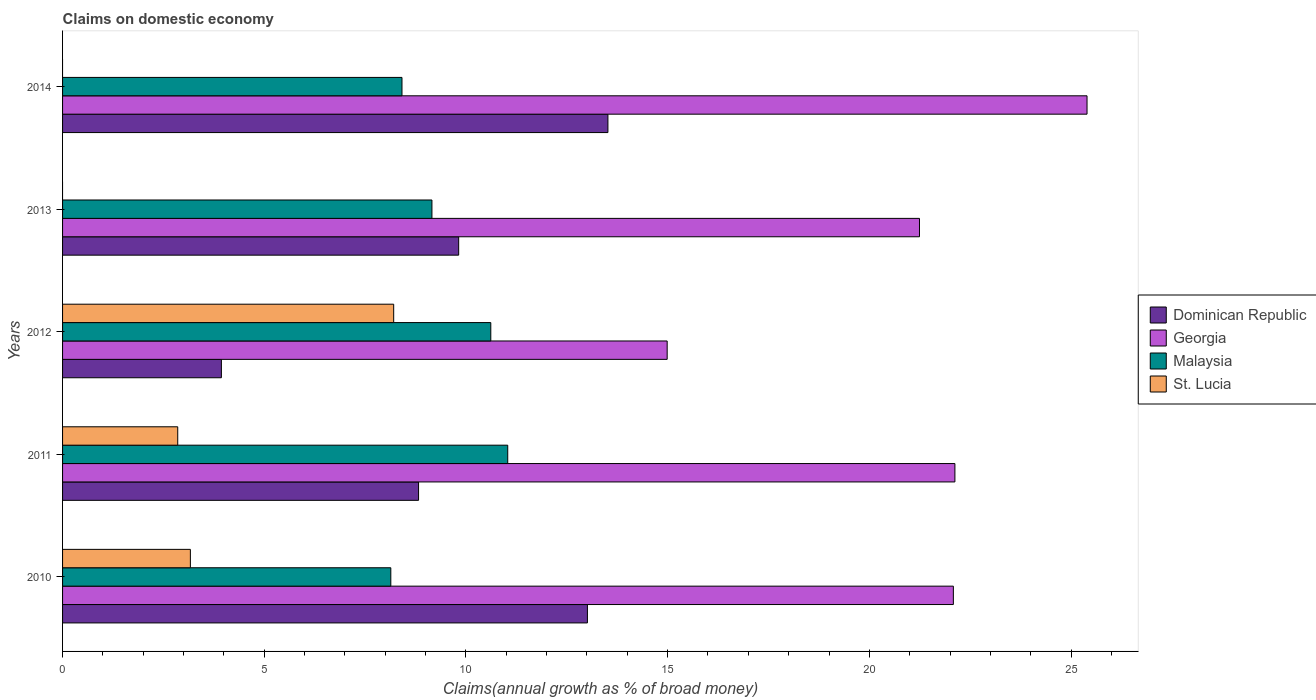How many groups of bars are there?
Your answer should be compact. 5. Are the number of bars per tick equal to the number of legend labels?
Give a very brief answer. No. What is the label of the 4th group of bars from the top?
Your response must be concise. 2011. What is the percentage of broad money claimed on domestic economy in Georgia in 2012?
Provide a short and direct response. 14.99. Across all years, what is the maximum percentage of broad money claimed on domestic economy in St. Lucia?
Provide a succinct answer. 8.21. Across all years, what is the minimum percentage of broad money claimed on domestic economy in Dominican Republic?
Ensure brevity in your answer.  3.94. In which year was the percentage of broad money claimed on domestic economy in Malaysia maximum?
Provide a succinct answer. 2011. What is the total percentage of broad money claimed on domestic economy in St. Lucia in the graph?
Provide a short and direct response. 14.23. What is the difference between the percentage of broad money claimed on domestic economy in Dominican Republic in 2011 and that in 2013?
Your response must be concise. -0.99. What is the difference between the percentage of broad money claimed on domestic economy in Malaysia in 2010 and the percentage of broad money claimed on domestic economy in St. Lucia in 2014?
Offer a very short reply. 8.14. What is the average percentage of broad money claimed on domestic economy in Dominican Republic per year?
Ensure brevity in your answer.  9.82. In the year 2010, what is the difference between the percentage of broad money claimed on domestic economy in Dominican Republic and percentage of broad money claimed on domestic economy in St. Lucia?
Your response must be concise. 9.84. In how many years, is the percentage of broad money claimed on domestic economy in Dominican Republic greater than 25 %?
Your response must be concise. 0. What is the ratio of the percentage of broad money claimed on domestic economy in Dominican Republic in 2011 to that in 2012?
Make the answer very short. 2.24. What is the difference between the highest and the second highest percentage of broad money claimed on domestic economy in Malaysia?
Keep it short and to the point. 0.42. What is the difference between the highest and the lowest percentage of broad money claimed on domestic economy in Georgia?
Your answer should be very brief. 10.41. In how many years, is the percentage of broad money claimed on domestic economy in Dominican Republic greater than the average percentage of broad money claimed on domestic economy in Dominican Republic taken over all years?
Keep it short and to the point. 2. Is the sum of the percentage of broad money claimed on domestic economy in Georgia in 2011 and 2013 greater than the maximum percentage of broad money claimed on domestic economy in St. Lucia across all years?
Your answer should be very brief. Yes. Is it the case that in every year, the sum of the percentage of broad money claimed on domestic economy in Georgia and percentage of broad money claimed on domestic economy in Malaysia is greater than the percentage of broad money claimed on domestic economy in St. Lucia?
Ensure brevity in your answer.  Yes. How many bars are there?
Your answer should be very brief. 18. What is the difference between two consecutive major ticks on the X-axis?
Make the answer very short. 5. Are the values on the major ticks of X-axis written in scientific E-notation?
Your answer should be compact. No. Does the graph contain any zero values?
Provide a short and direct response. Yes. Does the graph contain grids?
Ensure brevity in your answer.  No. How many legend labels are there?
Keep it short and to the point. 4. What is the title of the graph?
Keep it short and to the point. Claims on domestic economy. What is the label or title of the X-axis?
Your response must be concise. Claims(annual growth as % of broad money). What is the label or title of the Y-axis?
Your answer should be very brief. Years. What is the Claims(annual growth as % of broad money) of Dominican Republic in 2010?
Your answer should be compact. 13.01. What is the Claims(annual growth as % of broad money) of Georgia in 2010?
Offer a very short reply. 22.08. What is the Claims(annual growth as % of broad money) of Malaysia in 2010?
Keep it short and to the point. 8.14. What is the Claims(annual growth as % of broad money) of St. Lucia in 2010?
Your response must be concise. 3.17. What is the Claims(annual growth as % of broad money) of Dominican Republic in 2011?
Provide a succinct answer. 8.83. What is the Claims(annual growth as % of broad money) of Georgia in 2011?
Offer a terse response. 22.12. What is the Claims(annual growth as % of broad money) in Malaysia in 2011?
Your response must be concise. 11.04. What is the Claims(annual growth as % of broad money) of St. Lucia in 2011?
Your answer should be compact. 2.86. What is the Claims(annual growth as % of broad money) of Dominican Republic in 2012?
Make the answer very short. 3.94. What is the Claims(annual growth as % of broad money) in Georgia in 2012?
Give a very brief answer. 14.99. What is the Claims(annual growth as % of broad money) in Malaysia in 2012?
Keep it short and to the point. 10.62. What is the Claims(annual growth as % of broad money) of St. Lucia in 2012?
Give a very brief answer. 8.21. What is the Claims(annual growth as % of broad money) in Dominican Republic in 2013?
Your answer should be very brief. 9.82. What is the Claims(annual growth as % of broad money) of Georgia in 2013?
Offer a very short reply. 21.24. What is the Claims(annual growth as % of broad money) of Malaysia in 2013?
Provide a succinct answer. 9.16. What is the Claims(annual growth as % of broad money) of Dominican Republic in 2014?
Ensure brevity in your answer.  13.52. What is the Claims(annual growth as % of broad money) in Georgia in 2014?
Your response must be concise. 25.4. What is the Claims(annual growth as % of broad money) of Malaysia in 2014?
Provide a short and direct response. 8.41. Across all years, what is the maximum Claims(annual growth as % of broad money) in Dominican Republic?
Your answer should be very brief. 13.52. Across all years, what is the maximum Claims(annual growth as % of broad money) in Georgia?
Provide a short and direct response. 25.4. Across all years, what is the maximum Claims(annual growth as % of broad money) in Malaysia?
Offer a terse response. 11.04. Across all years, what is the maximum Claims(annual growth as % of broad money) in St. Lucia?
Your answer should be very brief. 8.21. Across all years, what is the minimum Claims(annual growth as % of broad money) in Dominican Republic?
Provide a short and direct response. 3.94. Across all years, what is the minimum Claims(annual growth as % of broad money) in Georgia?
Give a very brief answer. 14.99. Across all years, what is the minimum Claims(annual growth as % of broad money) in Malaysia?
Ensure brevity in your answer.  8.14. Across all years, what is the minimum Claims(annual growth as % of broad money) in St. Lucia?
Your answer should be compact. 0. What is the total Claims(annual growth as % of broad money) of Dominican Republic in the graph?
Your answer should be very brief. 49.11. What is the total Claims(annual growth as % of broad money) in Georgia in the graph?
Your answer should be compact. 105.83. What is the total Claims(annual growth as % of broad money) in Malaysia in the graph?
Give a very brief answer. 47.36. What is the total Claims(annual growth as % of broad money) of St. Lucia in the graph?
Ensure brevity in your answer.  14.23. What is the difference between the Claims(annual growth as % of broad money) of Dominican Republic in 2010 and that in 2011?
Ensure brevity in your answer.  4.19. What is the difference between the Claims(annual growth as % of broad money) in Georgia in 2010 and that in 2011?
Provide a short and direct response. -0.04. What is the difference between the Claims(annual growth as % of broad money) of Malaysia in 2010 and that in 2011?
Offer a very short reply. -2.9. What is the difference between the Claims(annual growth as % of broad money) of St. Lucia in 2010 and that in 2011?
Keep it short and to the point. 0.31. What is the difference between the Claims(annual growth as % of broad money) in Dominican Republic in 2010 and that in 2012?
Offer a terse response. 9.07. What is the difference between the Claims(annual growth as % of broad money) of Georgia in 2010 and that in 2012?
Your response must be concise. 7.09. What is the difference between the Claims(annual growth as % of broad money) in Malaysia in 2010 and that in 2012?
Your answer should be very brief. -2.48. What is the difference between the Claims(annual growth as % of broad money) of St. Lucia in 2010 and that in 2012?
Your answer should be very brief. -5.04. What is the difference between the Claims(annual growth as % of broad money) in Dominican Republic in 2010 and that in 2013?
Ensure brevity in your answer.  3.19. What is the difference between the Claims(annual growth as % of broad money) of Georgia in 2010 and that in 2013?
Your response must be concise. 0.84. What is the difference between the Claims(annual growth as % of broad money) in Malaysia in 2010 and that in 2013?
Ensure brevity in your answer.  -1.02. What is the difference between the Claims(annual growth as % of broad money) in Dominican Republic in 2010 and that in 2014?
Make the answer very short. -0.51. What is the difference between the Claims(annual growth as % of broad money) in Georgia in 2010 and that in 2014?
Your answer should be very brief. -3.31. What is the difference between the Claims(annual growth as % of broad money) of Malaysia in 2010 and that in 2014?
Your answer should be very brief. -0.28. What is the difference between the Claims(annual growth as % of broad money) of Dominican Republic in 2011 and that in 2012?
Your answer should be very brief. 4.89. What is the difference between the Claims(annual growth as % of broad money) of Georgia in 2011 and that in 2012?
Offer a very short reply. 7.13. What is the difference between the Claims(annual growth as % of broad money) of Malaysia in 2011 and that in 2012?
Offer a very short reply. 0.42. What is the difference between the Claims(annual growth as % of broad money) in St. Lucia in 2011 and that in 2012?
Offer a terse response. -5.35. What is the difference between the Claims(annual growth as % of broad money) in Dominican Republic in 2011 and that in 2013?
Your response must be concise. -0.99. What is the difference between the Claims(annual growth as % of broad money) of Georgia in 2011 and that in 2013?
Give a very brief answer. 0.88. What is the difference between the Claims(annual growth as % of broad money) of Malaysia in 2011 and that in 2013?
Ensure brevity in your answer.  1.88. What is the difference between the Claims(annual growth as % of broad money) in Dominican Republic in 2011 and that in 2014?
Ensure brevity in your answer.  -4.69. What is the difference between the Claims(annual growth as % of broad money) of Georgia in 2011 and that in 2014?
Provide a short and direct response. -3.28. What is the difference between the Claims(annual growth as % of broad money) in Malaysia in 2011 and that in 2014?
Make the answer very short. 2.62. What is the difference between the Claims(annual growth as % of broad money) of Dominican Republic in 2012 and that in 2013?
Offer a very short reply. -5.88. What is the difference between the Claims(annual growth as % of broad money) of Georgia in 2012 and that in 2013?
Give a very brief answer. -6.25. What is the difference between the Claims(annual growth as % of broad money) in Malaysia in 2012 and that in 2013?
Provide a succinct answer. 1.46. What is the difference between the Claims(annual growth as % of broad money) in Dominican Republic in 2012 and that in 2014?
Provide a short and direct response. -9.58. What is the difference between the Claims(annual growth as % of broad money) of Georgia in 2012 and that in 2014?
Your answer should be very brief. -10.41. What is the difference between the Claims(annual growth as % of broad money) of Malaysia in 2012 and that in 2014?
Keep it short and to the point. 2.2. What is the difference between the Claims(annual growth as % of broad money) of Dominican Republic in 2013 and that in 2014?
Your answer should be compact. -3.7. What is the difference between the Claims(annual growth as % of broad money) in Georgia in 2013 and that in 2014?
Your answer should be very brief. -4.15. What is the difference between the Claims(annual growth as % of broad money) in Malaysia in 2013 and that in 2014?
Your answer should be compact. 0.74. What is the difference between the Claims(annual growth as % of broad money) in Dominican Republic in 2010 and the Claims(annual growth as % of broad money) in Georgia in 2011?
Give a very brief answer. -9.11. What is the difference between the Claims(annual growth as % of broad money) in Dominican Republic in 2010 and the Claims(annual growth as % of broad money) in Malaysia in 2011?
Your answer should be compact. 1.98. What is the difference between the Claims(annual growth as % of broad money) of Dominican Republic in 2010 and the Claims(annual growth as % of broad money) of St. Lucia in 2011?
Your answer should be compact. 10.16. What is the difference between the Claims(annual growth as % of broad money) in Georgia in 2010 and the Claims(annual growth as % of broad money) in Malaysia in 2011?
Offer a very short reply. 11.05. What is the difference between the Claims(annual growth as % of broad money) of Georgia in 2010 and the Claims(annual growth as % of broad money) of St. Lucia in 2011?
Offer a very short reply. 19.23. What is the difference between the Claims(annual growth as % of broad money) of Malaysia in 2010 and the Claims(annual growth as % of broad money) of St. Lucia in 2011?
Make the answer very short. 5.28. What is the difference between the Claims(annual growth as % of broad money) in Dominican Republic in 2010 and the Claims(annual growth as % of broad money) in Georgia in 2012?
Make the answer very short. -1.98. What is the difference between the Claims(annual growth as % of broad money) in Dominican Republic in 2010 and the Claims(annual growth as % of broad money) in Malaysia in 2012?
Ensure brevity in your answer.  2.4. What is the difference between the Claims(annual growth as % of broad money) in Dominican Republic in 2010 and the Claims(annual growth as % of broad money) in St. Lucia in 2012?
Make the answer very short. 4.8. What is the difference between the Claims(annual growth as % of broad money) of Georgia in 2010 and the Claims(annual growth as % of broad money) of Malaysia in 2012?
Your answer should be compact. 11.47. What is the difference between the Claims(annual growth as % of broad money) of Georgia in 2010 and the Claims(annual growth as % of broad money) of St. Lucia in 2012?
Your answer should be very brief. 13.87. What is the difference between the Claims(annual growth as % of broad money) of Malaysia in 2010 and the Claims(annual growth as % of broad money) of St. Lucia in 2012?
Give a very brief answer. -0.07. What is the difference between the Claims(annual growth as % of broad money) in Dominican Republic in 2010 and the Claims(annual growth as % of broad money) in Georgia in 2013?
Keep it short and to the point. -8.23. What is the difference between the Claims(annual growth as % of broad money) of Dominican Republic in 2010 and the Claims(annual growth as % of broad money) of Malaysia in 2013?
Offer a terse response. 3.85. What is the difference between the Claims(annual growth as % of broad money) in Georgia in 2010 and the Claims(annual growth as % of broad money) in Malaysia in 2013?
Provide a short and direct response. 12.93. What is the difference between the Claims(annual growth as % of broad money) in Dominican Republic in 2010 and the Claims(annual growth as % of broad money) in Georgia in 2014?
Offer a very short reply. -12.39. What is the difference between the Claims(annual growth as % of broad money) in Dominican Republic in 2010 and the Claims(annual growth as % of broad money) in Malaysia in 2014?
Your answer should be compact. 4.6. What is the difference between the Claims(annual growth as % of broad money) of Georgia in 2010 and the Claims(annual growth as % of broad money) of Malaysia in 2014?
Make the answer very short. 13.67. What is the difference between the Claims(annual growth as % of broad money) of Dominican Republic in 2011 and the Claims(annual growth as % of broad money) of Georgia in 2012?
Provide a short and direct response. -6.16. What is the difference between the Claims(annual growth as % of broad money) of Dominican Republic in 2011 and the Claims(annual growth as % of broad money) of Malaysia in 2012?
Your response must be concise. -1.79. What is the difference between the Claims(annual growth as % of broad money) in Dominican Republic in 2011 and the Claims(annual growth as % of broad money) in St. Lucia in 2012?
Give a very brief answer. 0.62. What is the difference between the Claims(annual growth as % of broad money) in Georgia in 2011 and the Claims(annual growth as % of broad money) in Malaysia in 2012?
Ensure brevity in your answer.  11.51. What is the difference between the Claims(annual growth as % of broad money) of Georgia in 2011 and the Claims(annual growth as % of broad money) of St. Lucia in 2012?
Your response must be concise. 13.91. What is the difference between the Claims(annual growth as % of broad money) in Malaysia in 2011 and the Claims(annual growth as % of broad money) in St. Lucia in 2012?
Your response must be concise. 2.83. What is the difference between the Claims(annual growth as % of broad money) in Dominican Republic in 2011 and the Claims(annual growth as % of broad money) in Georgia in 2013?
Your response must be concise. -12.42. What is the difference between the Claims(annual growth as % of broad money) in Dominican Republic in 2011 and the Claims(annual growth as % of broad money) in Malaysia in 2013?
Keep it short and to the point. -0.33. What is the difference between the Claims(annual growth as % of broad money) of Georgia in 2011 and the Claims(annual growth as % of broad money) of Malaysia in 2013?
Offer a very short reply. 12.96. What is the difference between the Claims(annual growth as % of broad money) of Dominican Republic in 2011 and the Claims(annual growth as % of broad money) of Georgia in 2014?
Make the answer very short. -16.57. What is the difference between the Claims(annual growth as % of broad money) in Dominican Republic in 2011 and the Claims(annual growth as % of broad money) in Malaysia in 2014?
Provide a succinct answer. 0.41. What is the difference between the Claims(annual growth as % of broad money) in Georgia in 2011 and the Claims(annual growth as % of broad money) in Malaysia in 2014?
Your answer should be compact. 13.71. What is the difference between the Claims(annual growth as % of broad money) of Dominican Republic in 2012 and the Claims(annual growth as % of broad money) of Georgia in 2013?
Offer a very short reply. -17.31. What is the difference between the Claims(annual growth as % of broad money) of Dominican Republic in 2012 and the Claims(annual growth as % of broad money) of Malaysia in 2013?
Ensure brevity in your answer.  -5.22. What is the difference between the Claims(annual growth as % of broad money) in Georgia in 2012 and the Claims(annual growth as % of broad money) in Malaysia in 2013?
Offer a terse response. 5.83. What is the difference between the Claims(annual growth as % of broad money) in Dominican Republic in 2012 and the Claims(annual growth as % of broad money) in Georgia in 2014?
Your answer should be compact. -21.46. What is the difference between the Claims(annual growth as % of broad money) of Dominican Republic in 2012 and the Claims(annual growth as % of broad money) of Malaysia in 2014?
Your answer should be very brief. -4.48. What is the difference between the Claims(annual growth as % of broad money) of Georgia in 2012 and the Claims(annual growth as % of broad money) of Malaysia in 2014?
Your response must be concise. 6.57. What is the difference between the Claims(annual growth as % of broad money) in Dominican Republic in 2013 and the Claims(annual growth as % of broad money) in Georgia in 2014?
Your response must be concise. -15.58. What is the difference between the Claims(annual growth as % of broad money) in Dominican Republic in 2013 and the Claims(annual growth as % of broad money) in Malaysia in 2014?
Provide a succinct answer. 1.41. What is the difference between the Claims(annual growth as % of broad money) of Georgia in 2013 and the Claims(annual growth as % of broad money) of Malaysia in 2014?
Offer a very short reply. 12.83. What is the average Claims(annual growth as % of broad money) of Dominican Republic per year?
Provide a succinct answer. 9.82. What is the average Claims(annual growth as % of broad money) of Georgia per year?
Offer a very short reply. 21.17. What is the average Claims(annual growth as % of broad money) in Malaysia per year?
Give a very brief answer. 9.47. What is the average Claims(annual growth as % of broad money) in St. Lucia per year?
Keep it short and to the point. 2.85. In the year 2010, what is the difference between the Claims(annual growth as % of broad money) of Dominican Republic and Claims(annual growth as % of broad money) of Georgia?
Your response must be concise. -9.07. In the year 2010, what is the difference between the Claims(annual growth as % of broad money) in Dominican Republic and Claims(annual growth as % of broad money) in Malaysia?
Offer a terse response. 4.87. In the year 2010, what is the difference between the Claims(annual growth as % of broad money) of Dominican Republic and Claims(annual growth as % of broad money) of St. Lucia?
Your answer should be very brief. 9.84. In the year 2010, what is the difference between the Claims(annual growth as % of broad money) in Georgia and Claims(annual growth as % of broad money) in Malaysia?
Provide a short and direct response. 13.95. In the year 2010, what is the difference between the Claims(annual growth as % of broad money) in Georgia and Claims(annual growth as % of broad money) in St. Lucia?
Offer a very short reply. 18.91. In the year 2010, what is the difference between the Claims(annual growth as % of broad money) in Malaysia and Claims(annual growth as % of broad money) in St. Lucia?
Ensure brevity in your answer.  4.97. In the year 2011, what is the difference between the Claims(annual growth as % of broad money) in Dominican Republic and Claims(annual growth as % of broad money) in Georgia?
Your answer should be very brief. -13.3. In the year 2011, what is the difference between the Claims(annual growth as % of broad money) of Dominican Republic and Claims(annual growth as % of broad money) of Malaysia?
Provide a succinct answer. -2.21. In the year 2011, what is the difference between the Claims(annual growth as % of broad money) in Dominican Republic and Claims(annual growth as % of broad money) in St. Lucia?
Keep it short and to the point. 5.97. In the year 2011, what is the difference between the Claims(annual growth as % of broad money) in Georgia and Claims(annual growth as % of broad money) in Malaysia?
Offer a very short reply. 11.09. In the year 2011, what is the difference between the Claims(annual growth as % of broad money) of Georgia and Claims(annual growth as % of broad money) of St. Lucia?
Your answer should be very brief. 19.27. In the year 2011, what is the difference between the Claims(annual growth as % of broad money) in Malaysia and Claims(annual growth as % of broad money) in St. Lucia?
Your answer should be compact. 8.18. In the year 2012, what is the difference between the Claims(annual growth as % of broad money) of Dominican Republic and Claims(annual growth as % of broad money) of Georgia?
Provide a succinct answer. -11.05. In the year 2012, what is the difference between the Claims(annual growth as % of broad money) in Dominican Republic and Claims(annual growth as % of broad money) in Malaysia?
Provide a succinct answer. -6.68. In the year 2012, what is the difference between the Claims(annual growth as % of broad money) of Dominican Republic and Claims(annual growth as % of broad money) of St. Lucia?
Ensure brevity in your answer.  -4.27. In the year 2012, what is the difference between the Claims(annual growth as % of broad money) in Georgia and Claims(annual growth as % of broad money) in Malaysia?
Keep it short and to the point. 4.37. In the year 2012, what is the difference between the Claims(annual growth as % of broad money) in Georgia and Claims(annual growth as % of broad money) in St. Lucia?
Ensure brevity in your answer.  6.78. In the year 2012, what is the difference between the Claims(annual growth as % of broad money) of Malaysia and Claims(annual growth as % of broad money) of St. Lucia?
Your answer should be compact. 2.41. In the year 2013, what is the difference between the Claims(annual growth as % of broad money) of Dominican Republic and Claims(annual growth as % of broad money) of Georgia?
Provide a short and direct response. -11.42. In the year 2013, what is the difference between the Claims(annual growth as % of broad money) in Dominican Republic and Claims(annual growth as % of broad money) in Malaysia?
Ensure brevity in your answer.  0.66. In the year 2013, what is the difference between the Claims(annual growth as % of broad money) of Georgia and Claims(annual growth as % of broad money) of Malaysia?
Offer a terse response. 12.09. In the year 2014, what is the difference between the Claims(annual growth as % of broad money) of Dominican Republic and Claims(annual growth as % of broad money) of Georgia?
Your answer should be compact. -11.88. In the year 2014, what is the difference between the Claims(annual growth as % of broad money) in Dominican Republic and Claims(annual growth as % of broad money) in Malaysia?
Ensure brevity in your answer.  5.11. In the year 2014, what is the difference between the Claims(annual growth as % of broad money) of Georgia and Claims(annual growth as % of broad money) of Malaysia?
Give a very brief answer. 16.98. What is the ratio of the Claims(annual growth as % of broad money) in Dominican Republic in 2010 to that in 2011?
Give a very brief answer. 1.47. What is the ratio of the Claims(annual growth as % of broad money) in Malaysia in 2010 to that in 2011?
Keep it short and to the point. 0.74. What is the ratio of the Claims(annual growth as % of broad money) in St. Lucia in 2010 to that in 2011?
Ensure brevity in your answer.  1.11. What is the ratio of the Claims(annual growth as % of broad money) in Dominican Republic in 2010 to that in 2012?
Your answer should be compact. 3.3. What is the ratio of the Claims(annual growth as % of broad money) in Georgia in 2010 to that in 2012?
Make the answer very short. 1.47. What is the ratio of the Claims(annual growth as % of broad money) of Malaysia in 2010 to that in 2012?
Offer a very short reply. 0.77. What is the ratio of the Claims(annual growth as % of broad money) of St. Lucia in 2010 to that in 2012?
Your answer should be very brief. 0.39. What is the ratio of the Claims(annual growth as % of broad money) in Dominican Republic in 2010 to that in 2013?
Your response must be concise. 1.32. What is the ratio of the Claims(annual growth as % of broad money) of Georgia in 2010 to that in 2013?
Your response must be concise. 1.04. What is the ratio of the Claims(annual growth as % of broad money) in Malaysia in 2010 to that in 2013?
Offer a terse response. 0.89. What is the ratio of the Claims(annual growth as % of broad money) of Dominican Republic in 2010 to that in 2014?
Your answer should be compact. 0.96. What is the ratio of the Claims(annual growth as % of broad money) of Georgia in 2010 to that in 2014?
Your answer should be compact. 0.87. What is the ratio of the Claims(annual growth as % of broad money) of Malaysia in 2010 to that in 2014?
Your answer should be compact. 0.97. What is the ratio of the Claims(annual growth as % of broad money) in Dominican Republic in 2011 to that in 2012?
Keep it short and to the point. 2.24. What is the ratio of the Claims(annual growth as % of broad money) of Georgia in 2011 to that in 2012?
Ensure brevity in your answer.  1.48. What is the ratio of the Claims(annual growth as % of broad money) in Malaysia in 2011 to that in 2012?
Ensure brevity in your answer.  1.04. What is the ratio of the Claims(annual growth as % of broad money) of St. Lucia in 2011 to that in 2012?
Your answer should be very brief. 0.35. What is the ratio of the Claims(annual growth as % of broad money) of Dominican Republic in 2011 to that in 2013?
Offer a terse response. 0.9. What is the ratio of the Claims(annual growth as % of broad money) in Georgia in 2011 to that in 2013?
Ensure brevity in your answer.  1.04. What is the ratio of the Claims(annual growth as % of broad money) in Malaysia in 2011 to that in 2013?
Make the answer very short. 1.21. What is the ratio of the Claims(annual growth as % of broad money) in Dominican Republic in 2011 to that in 2014?
Your response must be concise. 0.65. What is the ratio of the Claims(annual growth as % of broad money) of Georgia in 2011 to that in 2014?
Provide a succinct answer. 0.87. What is the ratio of the Claims(annual growth as % of broad money) of Malaysia in 2011 to that in 2014?
Your answer should be very brief. 1.31. What is the ratio of the Claims(annual growth as % of broad money) in Dominican Republic in 2012 to that in 2013?
Make the answer very short. 0.4. What is the ratio of the Claims(annual growth as % of broad money) of Georgia in 2012 to that in 2013?
Give a very brief answer. 0.71. What is the ratio of the Claims(annual growth as % of broad money) of Malaysia in 2012 to that in 2013?
Give a very brief answer. 1.16. What is the ratio of the Claims(annual growth as % of broad money) in Dominican Republic in 2012 to that in 2014?
Provide a succinct answer. 0.29. What is the ratio of the Claims(annual growth as % of broad money) in Georgia in 2012 to that in 2014?
Offer a terse response. 0.59. What is the ratio of the Claims(annual growth as % of broad money) in Malaysia in 2012 to that in 2014?
Your answer should be very brief. 1.26. What is the ratio of the Claims(annual growth as % of broad money) in Dominican Republic in 2013 to that in 2014?
Your answer should be compact. 0.73. What is the ratio of the Claims(annual growth as % of broad money) in Georgia in 2013 to that in 2014?
Your answer should be very brief. 0.84. What is the ratio of the Claims(annual growth as % of broad money) of Malaysia in 2013 to that in 2014?
Offer a terse response. 1.09. What is the difference between the highest and the second highest Claims(annual growth as % of broad money) in Dominican Republic?
Give a very brief answer. 0.51. What is the difference between the highest and the second highest Claims(annual growth as % of broad money) of Georgia?
Provide a succinct answer. 3.28. What is the difference between the highest and the second highest Claims(annual growth as % of broad money) in Malaysia?
Keep it short and to the point. 0.42. What is the difference between the highest and the second highest Claims(annual growth as % of broad money) in St. Lucia?
Ensure brevity in your answer.  5.04. What is the difference between the highest and the lowest Claims(annual growth as % of broad money) in Dominican Republic?
Make the answer very short. 9.58. What is the difference between the highest and the lowest Claims(annual growth as % of broad money) of Georgia?
Make the answer very short. 10.41. What is the difference between the highest and the lowest Claims(annual growth as % of broad money) of Malaysia?
Make the answer very short. 2.9. What is the difference between the highest and the lowest Claims(annual growth as % of broad money) of St. Lucia?
Keep it short and to the point. 8.21. 